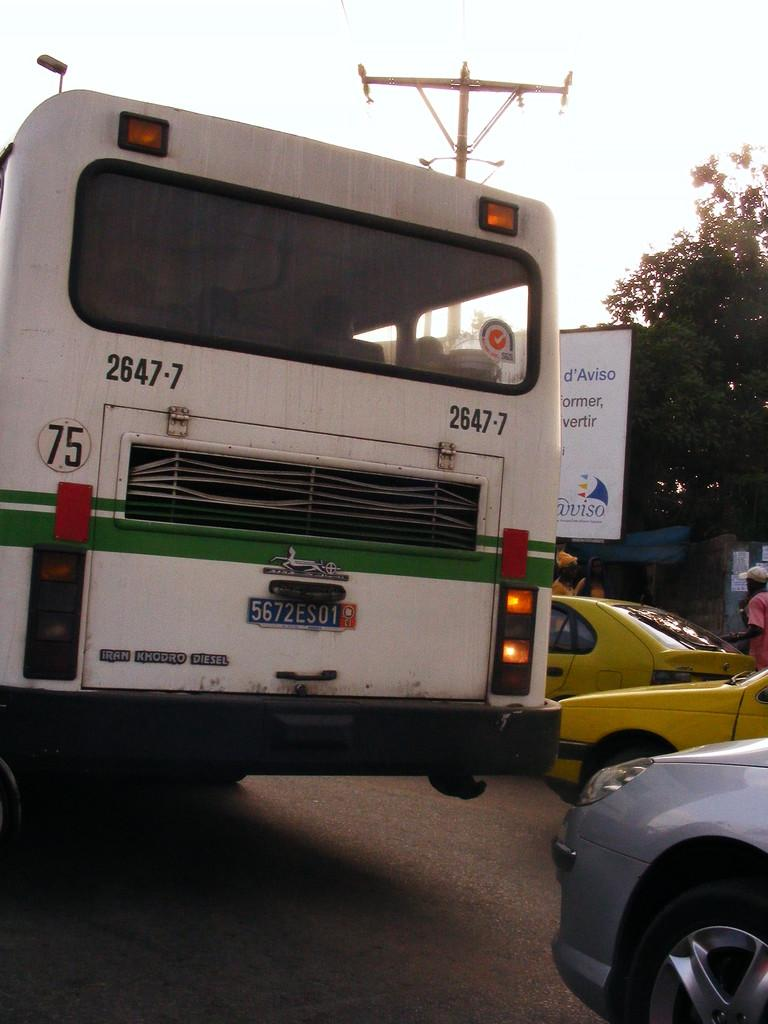<image>
Write a terse but informative summary of the picture. road scene with a back of a bus number 75 